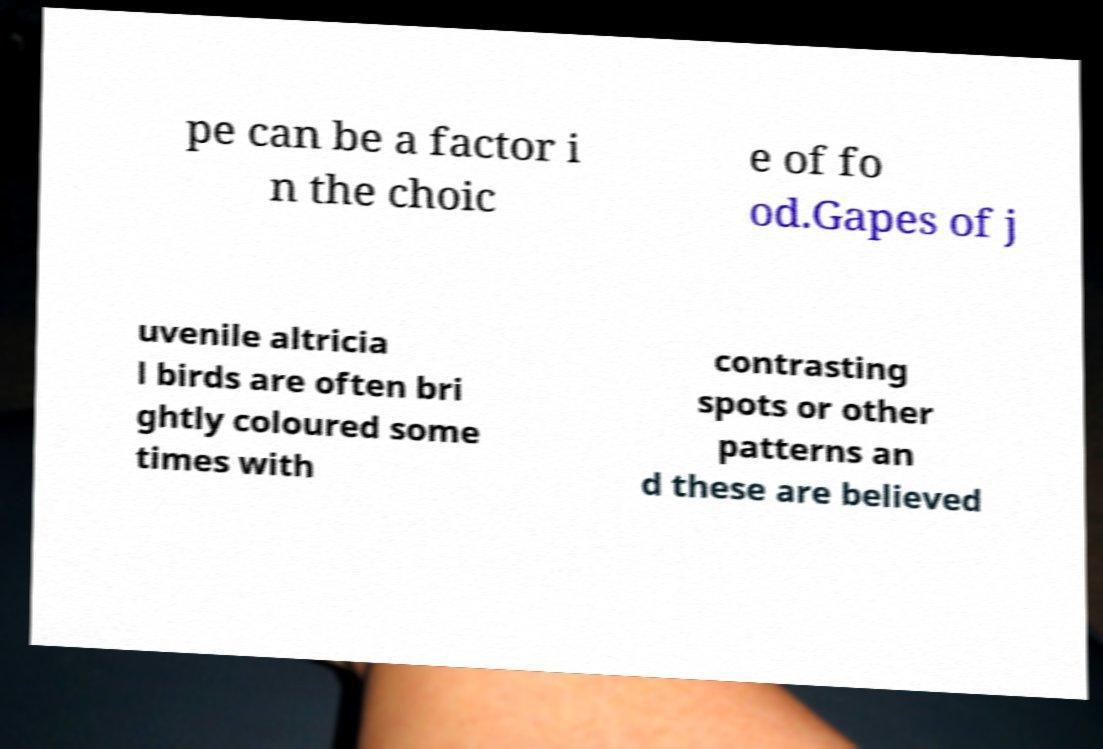Could you assist in decoding the text presented in this image and type it out clearly? pe can be a factor i n the choic e of fo od.Gapes of j uvenile altricia l birds are often bri ghtly coloured some times with contrasting spots or other patterns an d these are believed 